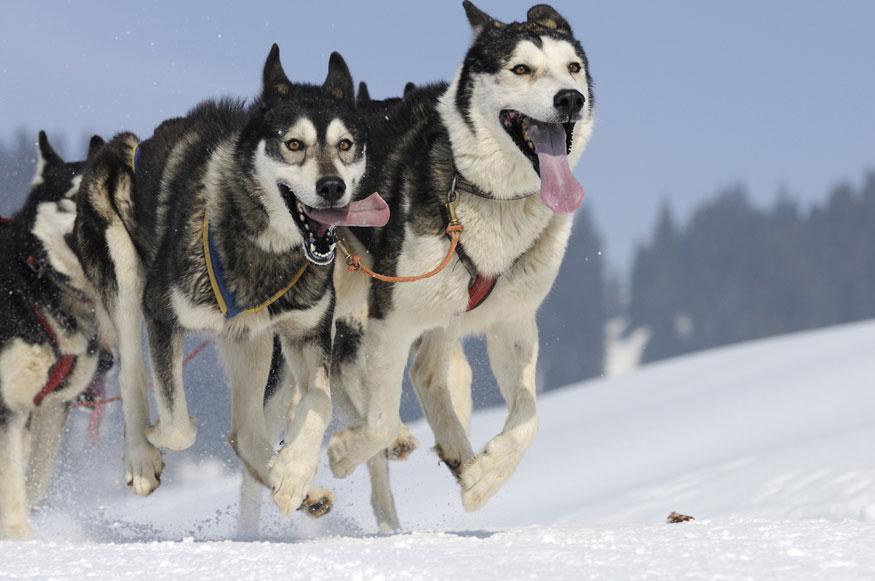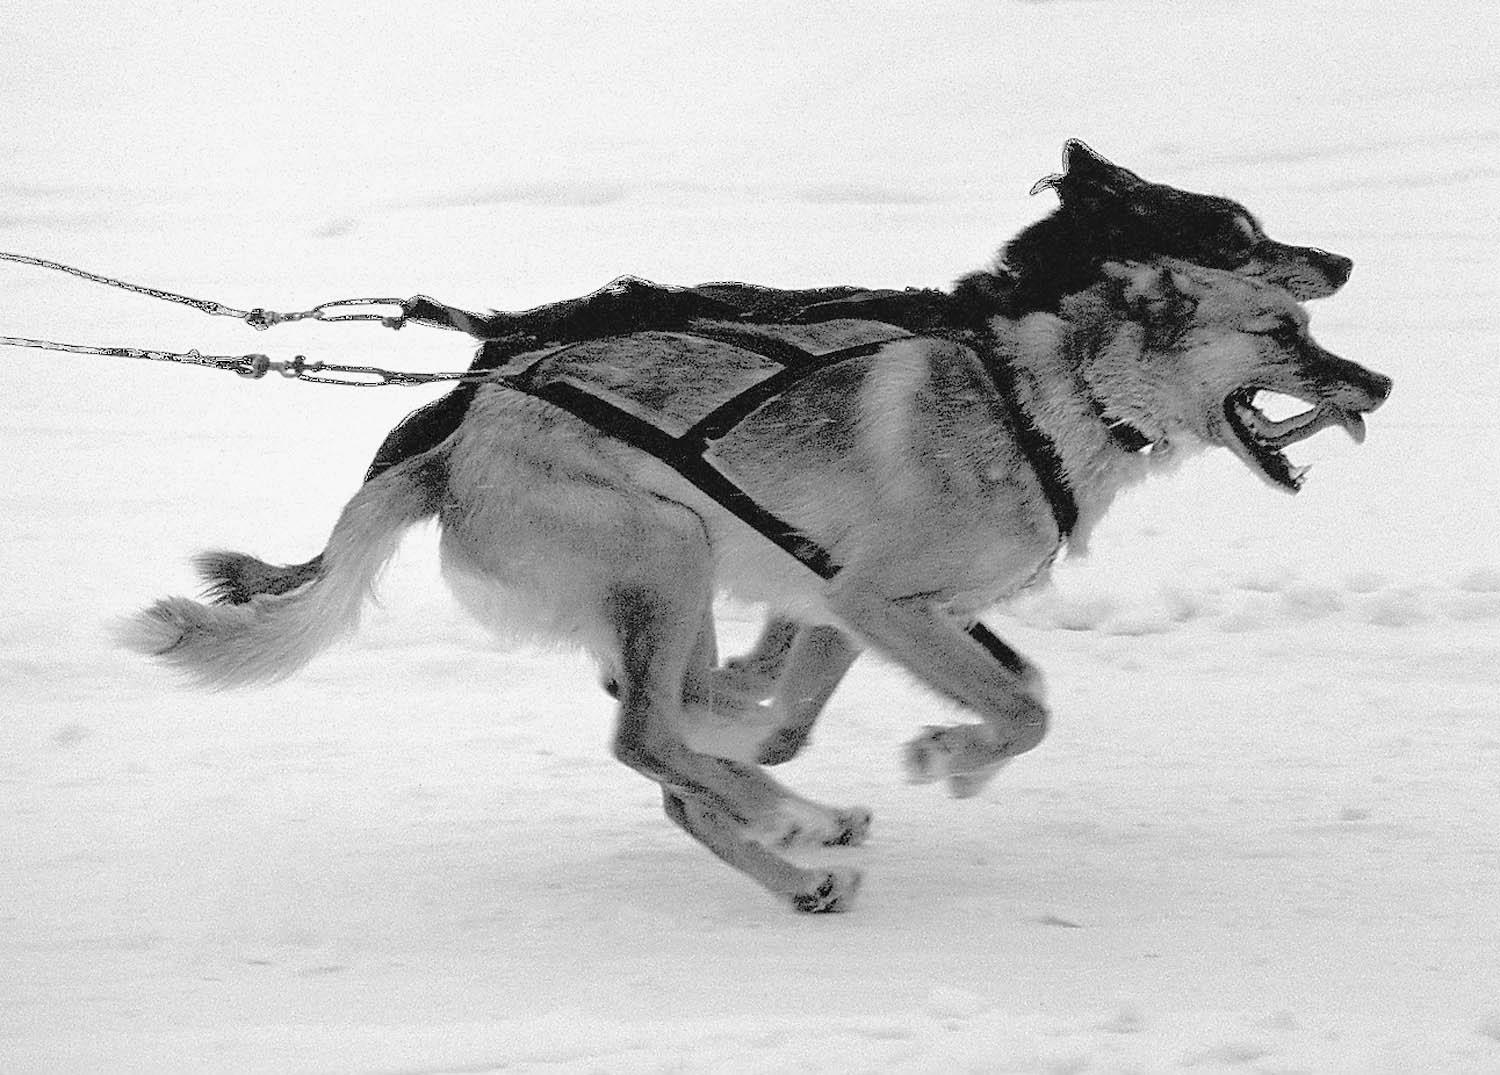The first image is the image on the left, the second image is the image on the right. For the images shown, is this caption "Each image shows a sled driver behind a team of dogs moving forward over snow, and a lead dog wears black booties in the team on the right." true? Answer yes or no. No. The first image is the image on the left, the second image is the image on the right. Analyze the images presented: Is the assertion "There are 2 people holding onto a sled." valid? Answer yes or no. No. 